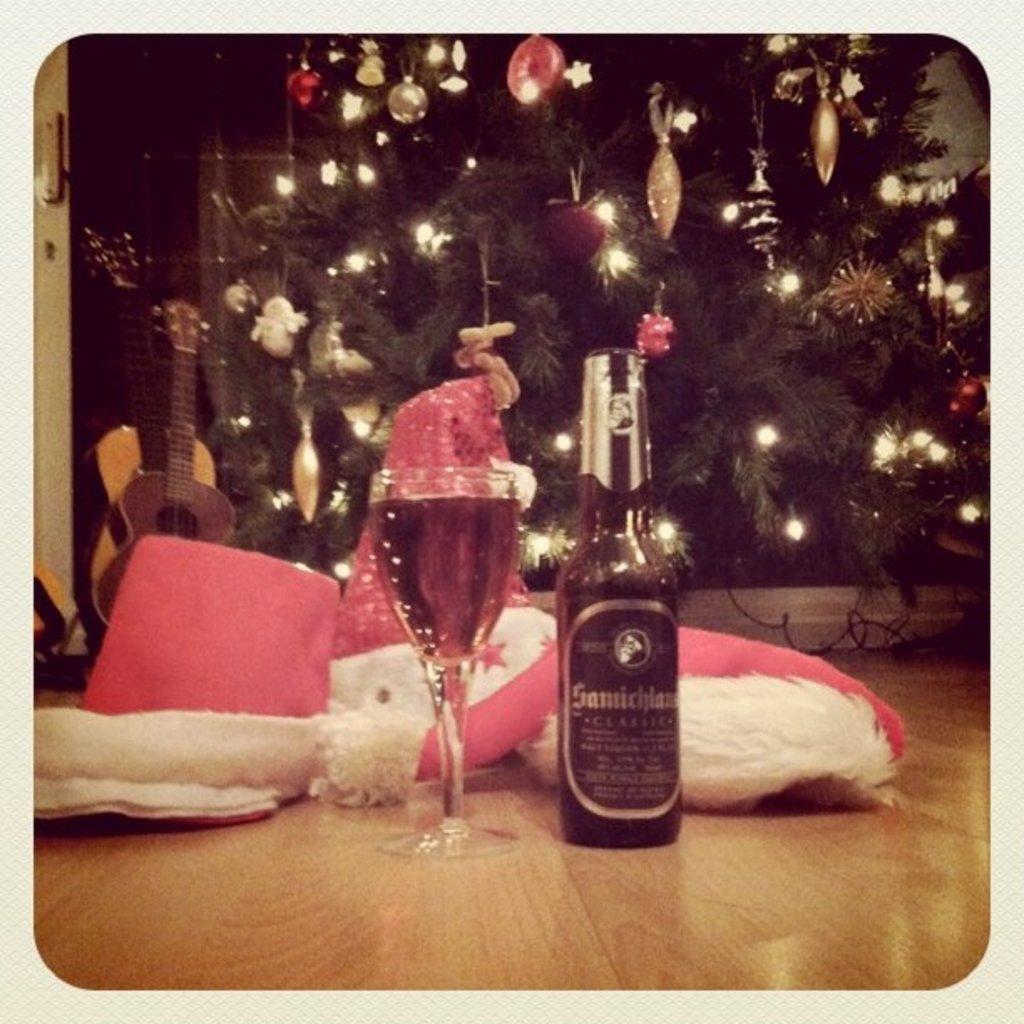Could you give a brief overview of what you see in this image? In this picture, we see a glass containing the liquid and a glass bottle. Behind that, we see the clothes in white and red color. In the background, we see a guitar and a Christmas tree which is decorated with the lights and the balls. This picture might be a photo frame. 